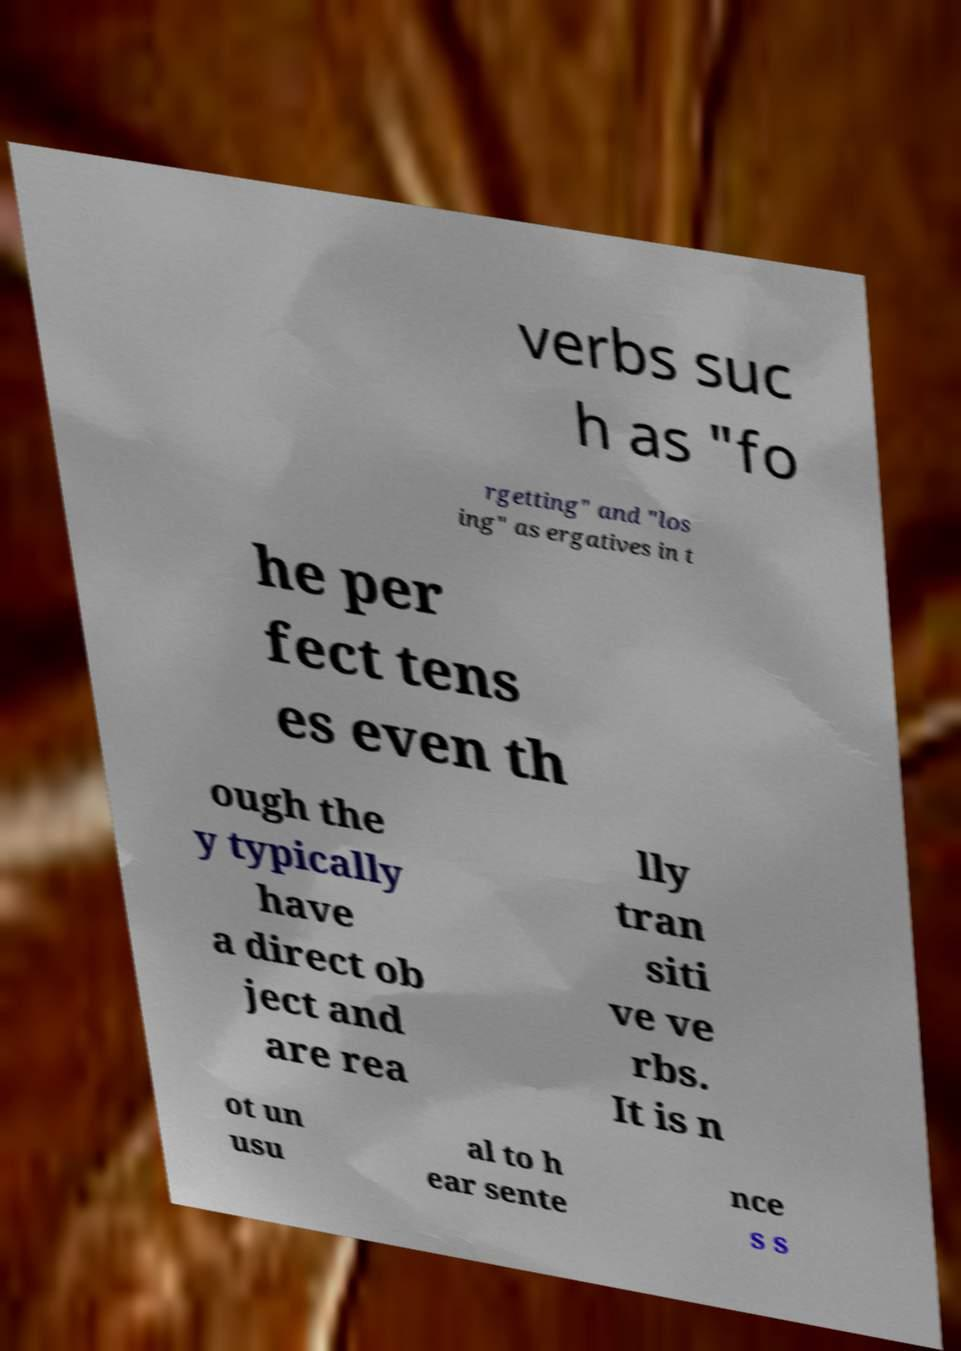There's text embedded in this image that I need extracted. Can you transcribe it verbatim? verbs suc h as "fo rgetting" and "los ing" as ergatives in t he per fect tens es even th ough the y typically have a direct ob ject and are rea lly tran siti ve ve rbs. It is n ot un usu al to h ear sente nce s s 